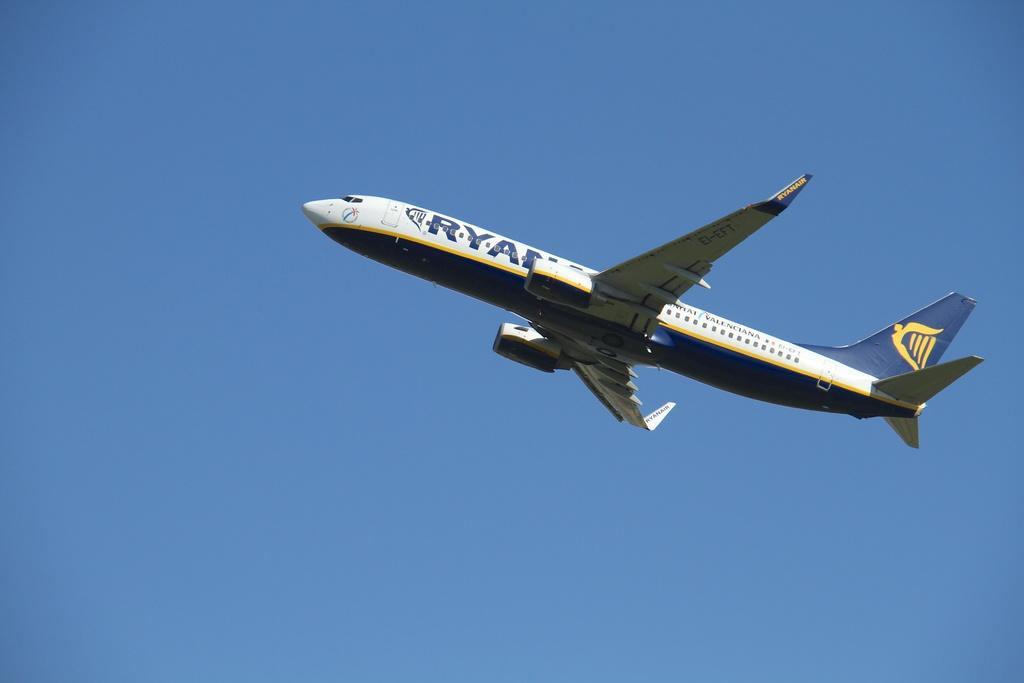Please provide a concise description of this image. In the center of the image there is a aeroplane. In the background of the image there is sky. 